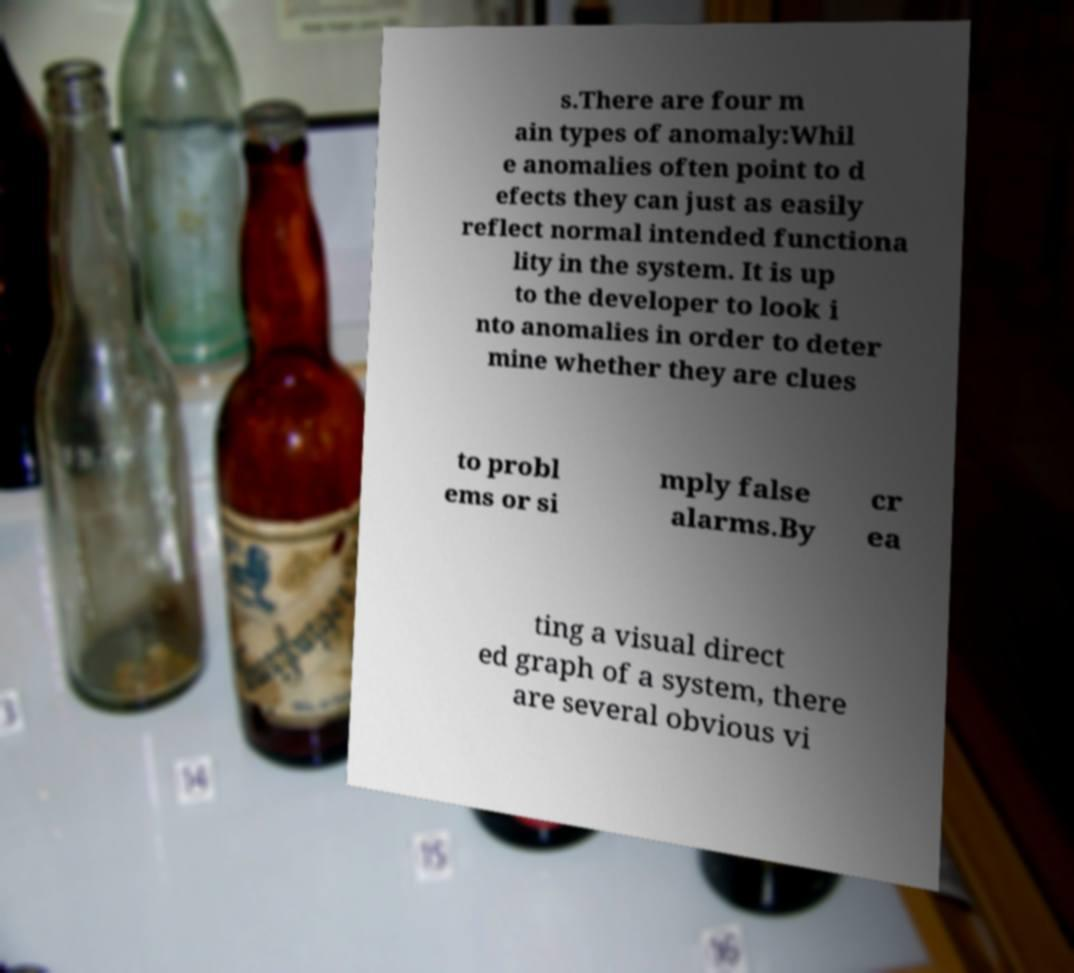Could you extract and type out the text from this image? s.There are four m ain types of anomaly:Whil e anomalies often point to d efects they can just as easily reflect normal intended functiona lity in the system. It is up to the developer to look i nto anomalies in order to deter mine whether they are clues to probl ems or si mply false alarms.By cr ea ting a visual direct ed graph of a system, there are several obvious vi 